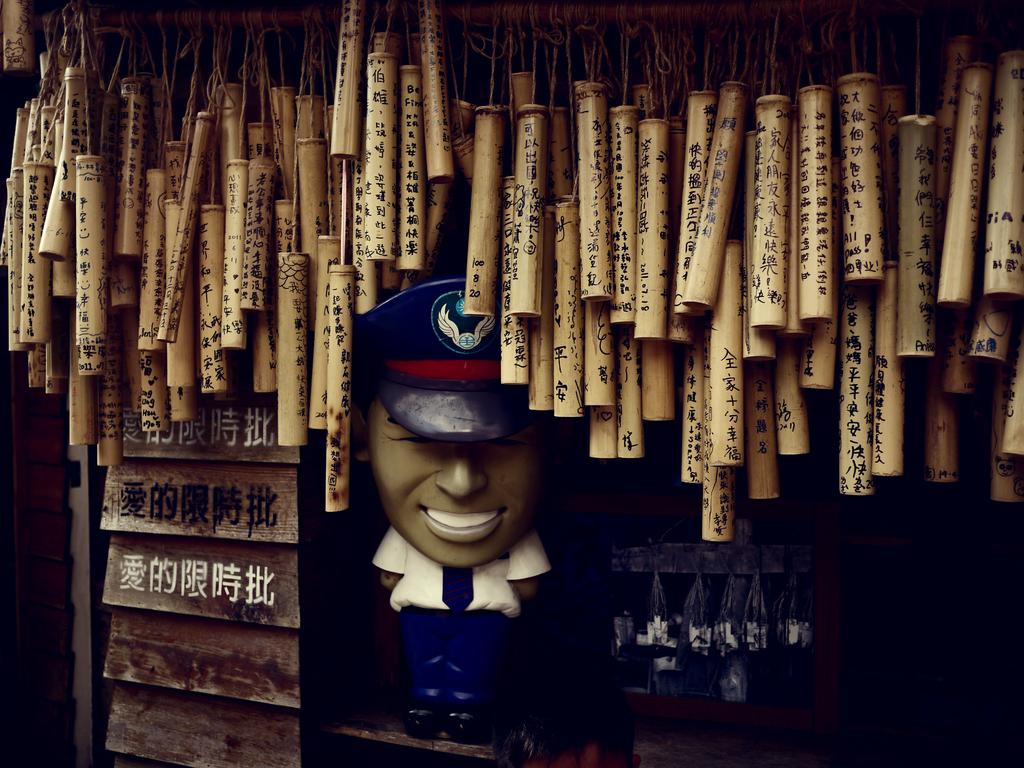What language is on the bats?
Make the answer very short. Chinese. 